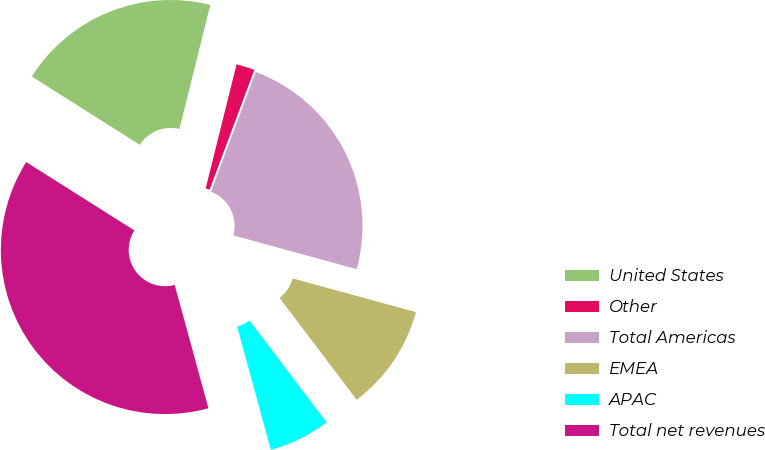<chart> <loc_0><loc_0><loc_500><loc_500><pie_chart><fcel>United States<fcel>Other<fcel>Total Americas<fcel>EMEA<fcel>APAC<fcel>Total net revenues<nl><fcel>19.91%<fcel>1.81%<fcel>23.55%<fcel>10.44%<fcel>6.06%<fcel>38.22%<nl></chart> 